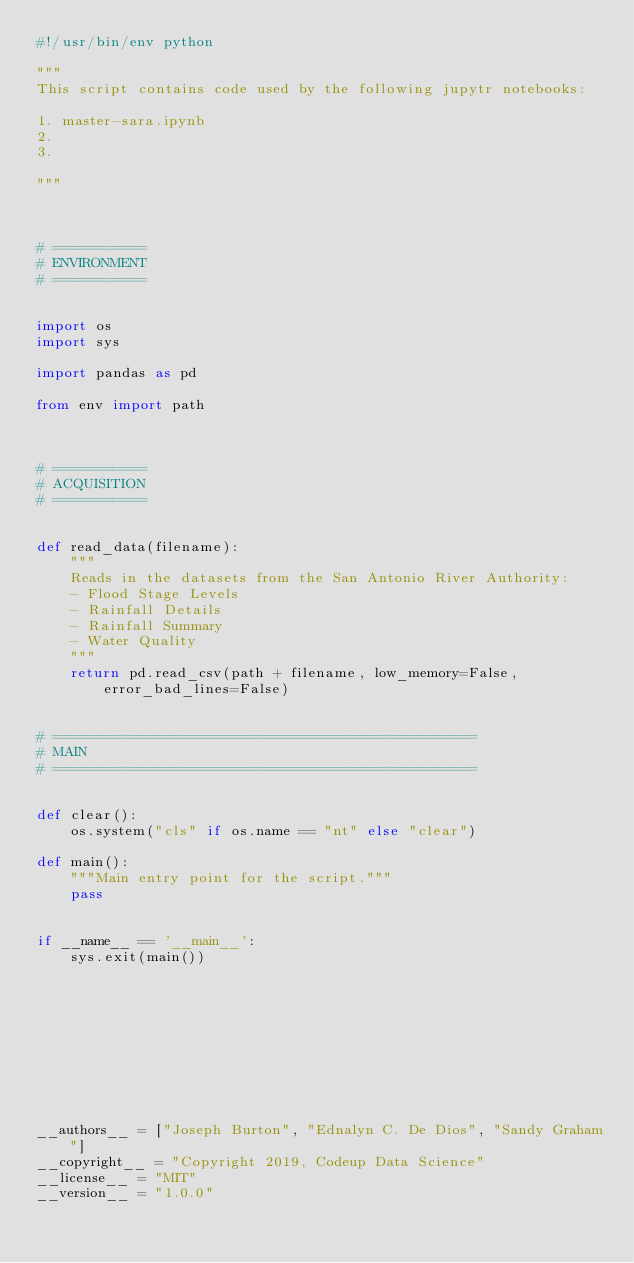Convert code to text. <code><loc_0><loc_0><loc_500><loc_500><_Python_>#!/usr/bin/env python

"""
This script contains code used by the following jupytr notebooks:

1. master-sara.ipynb
2.
3.

"""



# ===========
# ENVIRONMENT
# ===========


import os
import sys

import pandas as pd

from env import path



# ===========
# ACQUISITION
# ===========


def read_data(filename):
	"""
	Reads in the datasets from the San Antonio River Authority:
    - Flood Stage Levels
    - Rainfall Details
    - Rainfall Summary
    - Water Quality
	"""
	return pd.read_csv(path + filename, low_memory=False, error_bad_lines=False)
    

# ==================================================
# MAIN
# ==================================================


def clear():
	os.system("cls" if os.name == "nt" else "clear")

def main():
    """Main entry point for the script."""
    pass


if __name__ == '__main__':
    sys.exit(main())










__authors__ = ["Joseph Burton", "Ednalyn C. De Dios", "Sandy Graham"]
__copyright__ = "Copyright 2019, Codeup Data Science"
__license__ = "MIT"
__version__ = "1.0.0"</code> 